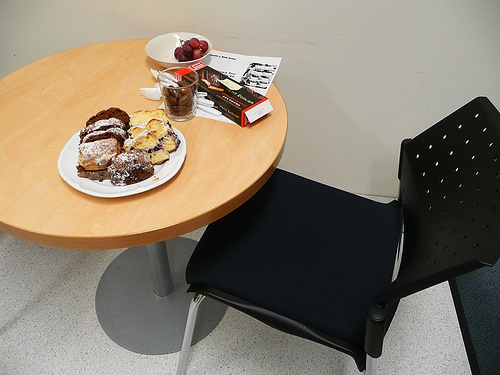Describe the objects in this image and their specific colors. I can see dining table in gray, tan, and lightgray tones, chair in gray, black, darkgray, and darkgreen tones, cup in gray, maroon, black, and lightgray tones, bowl in gray, lightgray, maroon, and black tones, and cake in gray, lightgray, tan, and maroon tones in this image. 